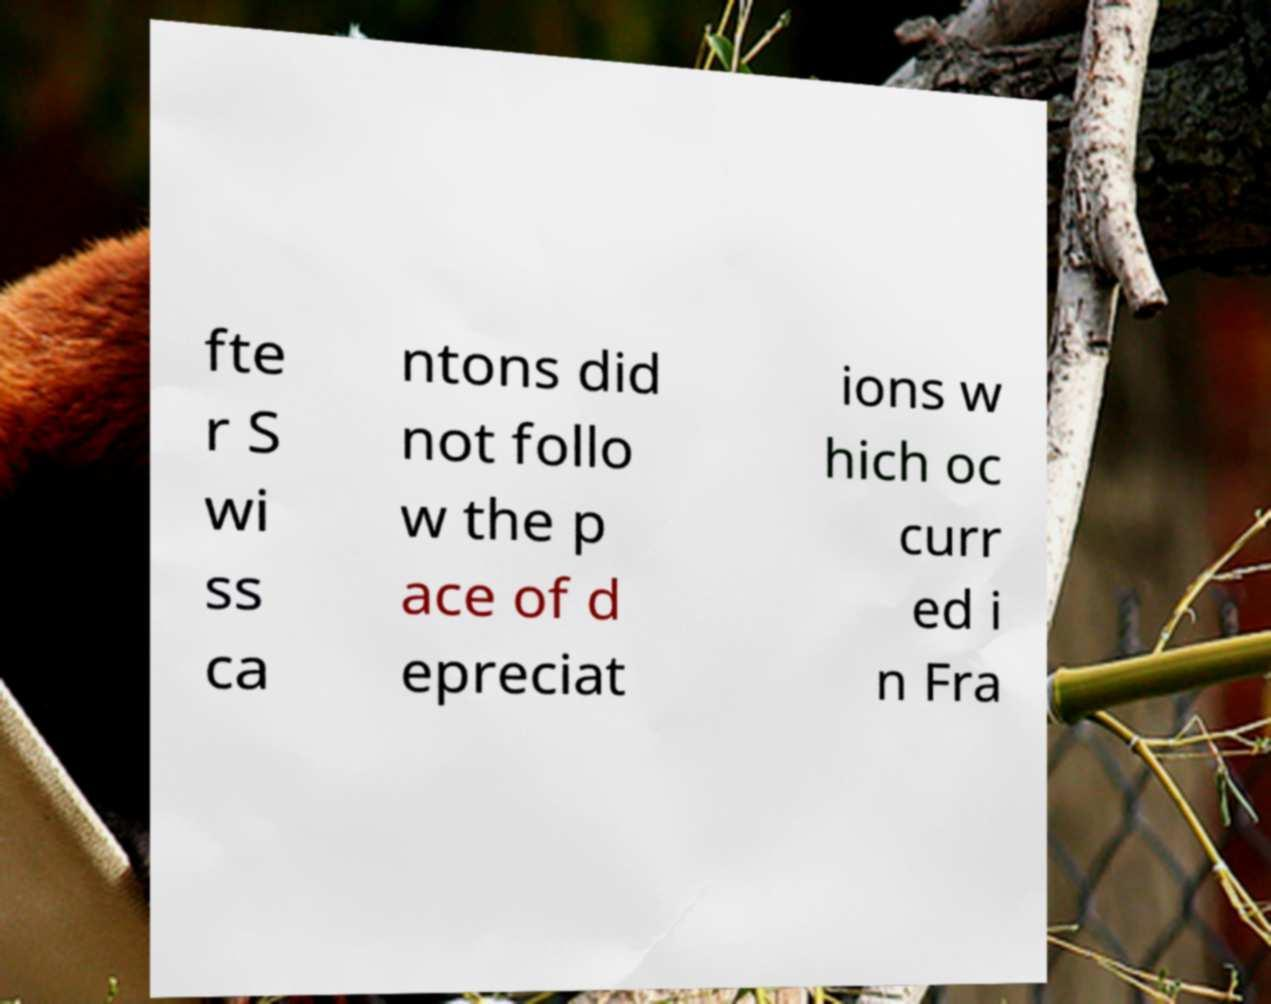What messages or text are displayed in this image? I need them in a readable, typed format. fte r S wi ss ca ntons did not follo w the p ace of d epreciat ions w hich oc curr ed i n Fra 